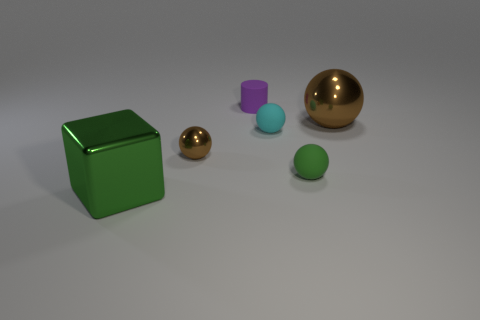Add 3 tiny purple objects. How many objects exist? 9 Subtract all green spheres. How many spheres are left? 3 Subtract all small spheres. How many spheres are left? 1 Subtract 1 balls. How many balls are left? 3 Subtract all yellow blocks. Subtract all purple balls. How many blocks are left? 1 Subtract all blue blocks. How many brown balls are left? 2 Subtract all tiny cylinders. Subtract all brown blocks. How many objects are left? 5 Add 2 big green cubes. How many big green cubes are left? 3 Add 6 tiny purple metal cubes. How many tiny purple metal cubes exist? 6 Subtract 0 gray cylinders. How many objects are left? 6 